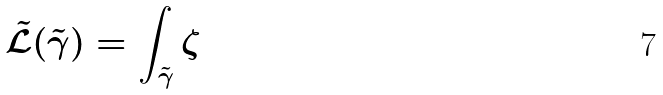Convert formula to latex. <formula><loc_0><loc_0><loc_500><loc_500>\mathcal { \tilde { L } } ( \tilde { \gamma } ) = \int _ { \tilde { \gamma } } \zeta</formula> 